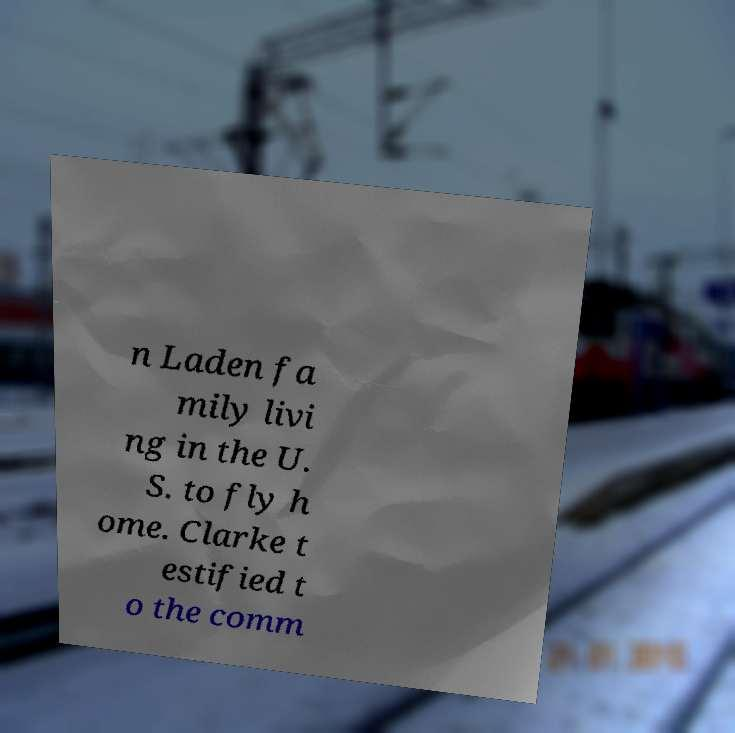Could you extract and type out the text from this image? n Laden fa mily livi ng in the U. S. to fly h ome. Clarke t estified t o the comm 